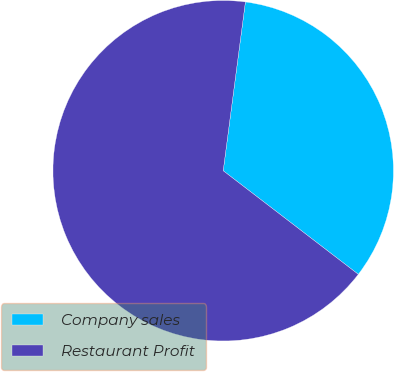<chart> <loc_0><loc_0><loc_500><loc_500><pie_chart><fcel>Company sales<fcel>Restaurant Profit<nl><fcel>33.33%<fcel>66.67%<nl></chart> 